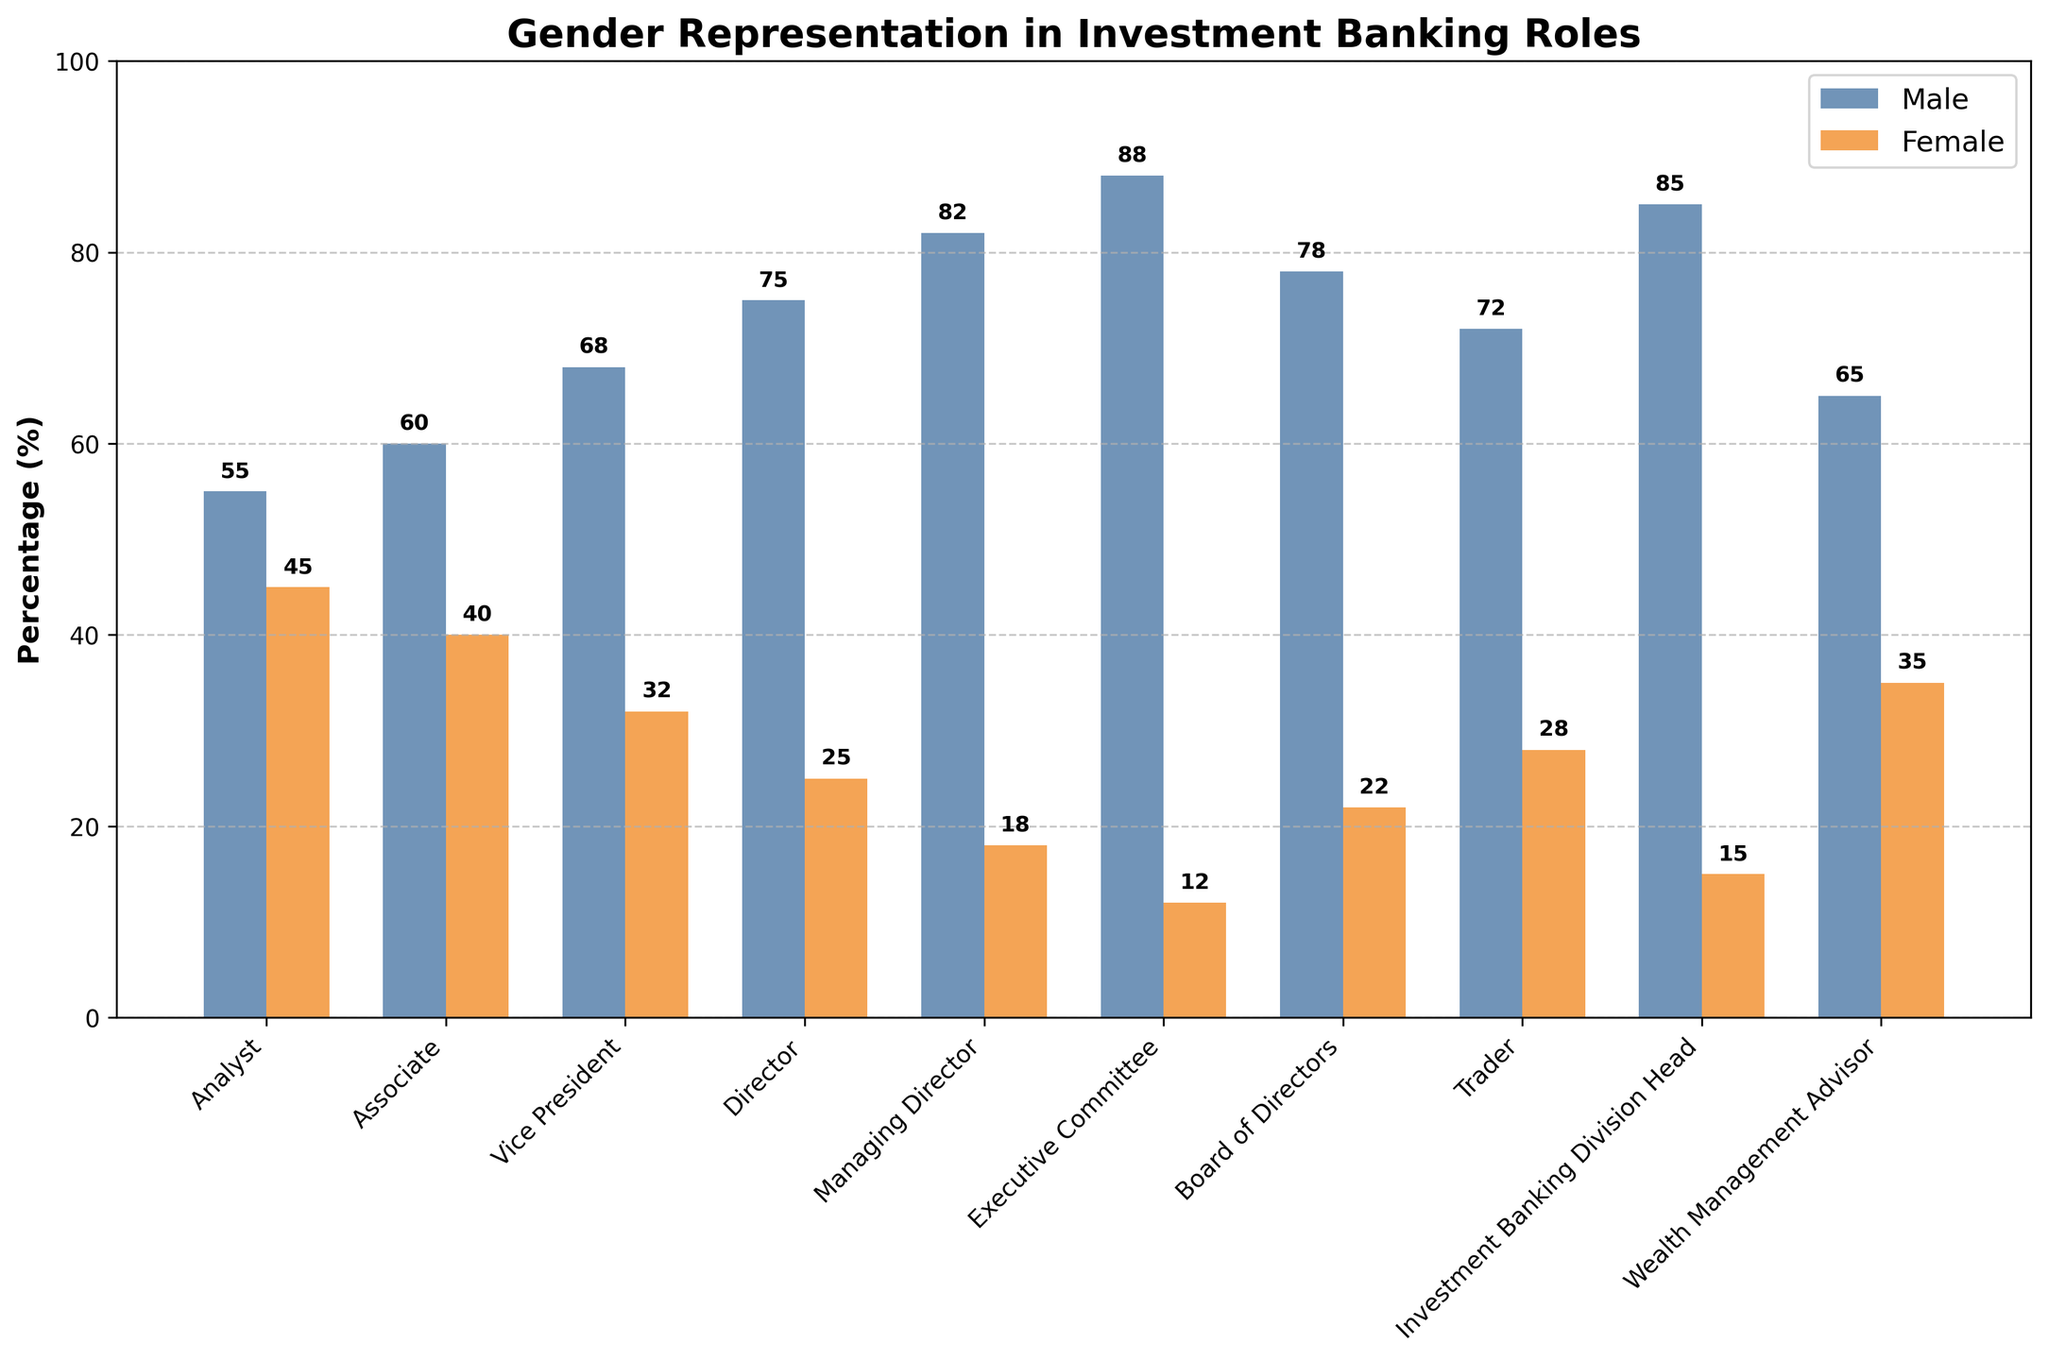What is the percentage of female representation at the Director level? Look at the bar corresponding to the Director role. The height of the female bar indicates 25%.
Answer: 25% Which role has a higher percentage of female representation, Analyst or Wealth Management Advisor? Compare the heights of the female bars for the Analyst and Wealth Management Advisor roles. Analyst has 45%, and Wealth Management Advisor has 35%.
Answer: Analyst By how much does the male representation in the Executive Committee exceed that of the Board of Directors? Subtract the male percentage of the Board of Directors (78%) from that of the Executive Committee (88%). 88% - 78% = 10%.
Answer: 10% What's the average percentage of female representation across all the roles displayed? Sum the female percentages for all roles and divide by the number of roles. (45 + 40 + 32 + 25 + 18 + 12 + 22 + 28 + 15 + 35) / 10 = 27.2%
Answer: 27.2% Is female representation higher at the Vice President or Trader level? Compare the heights of the female bars for Vice President and Trader. Vice President has 32%, and Trader has 28%.
Answer: Vice President What is the combined percentage for male representation in the Associate and Managing Director roles? Sum the male percentages for the Associate (60%) and Managing Director (82%) roles. 60% + 82% = 142%
Answer: 142% Which role has the lowest female representation, and what is the percentage? Identify the shortest female bar and look at its label. The Executive Committee has the lowest at 12%.
Answer: Executive Committee, 12% How much higher is the male representation at the Vice President level compared to the Analyst level? Subtract the male percentage at the Analyst level (55%) from the Vice President level (68%). 68% - 55% = 13%
Answer: 13% What’s the total percentage of both male and female representations at the Board of Directors level? Sum the male and female percentages for the Board of Directors. 78% + 22% = 100%
Answer: 100% Which roles have a gender gap of 50% or more between male and female representation? Identify roles where the difference between male and female percentages is 50% or more. Director (50%), Managing Director (64%), Executive Committee (76%), Investment Banking Division Head (70%)
Answer: Director, Managing Director, Executive Committee, Investment Banking Division Head 